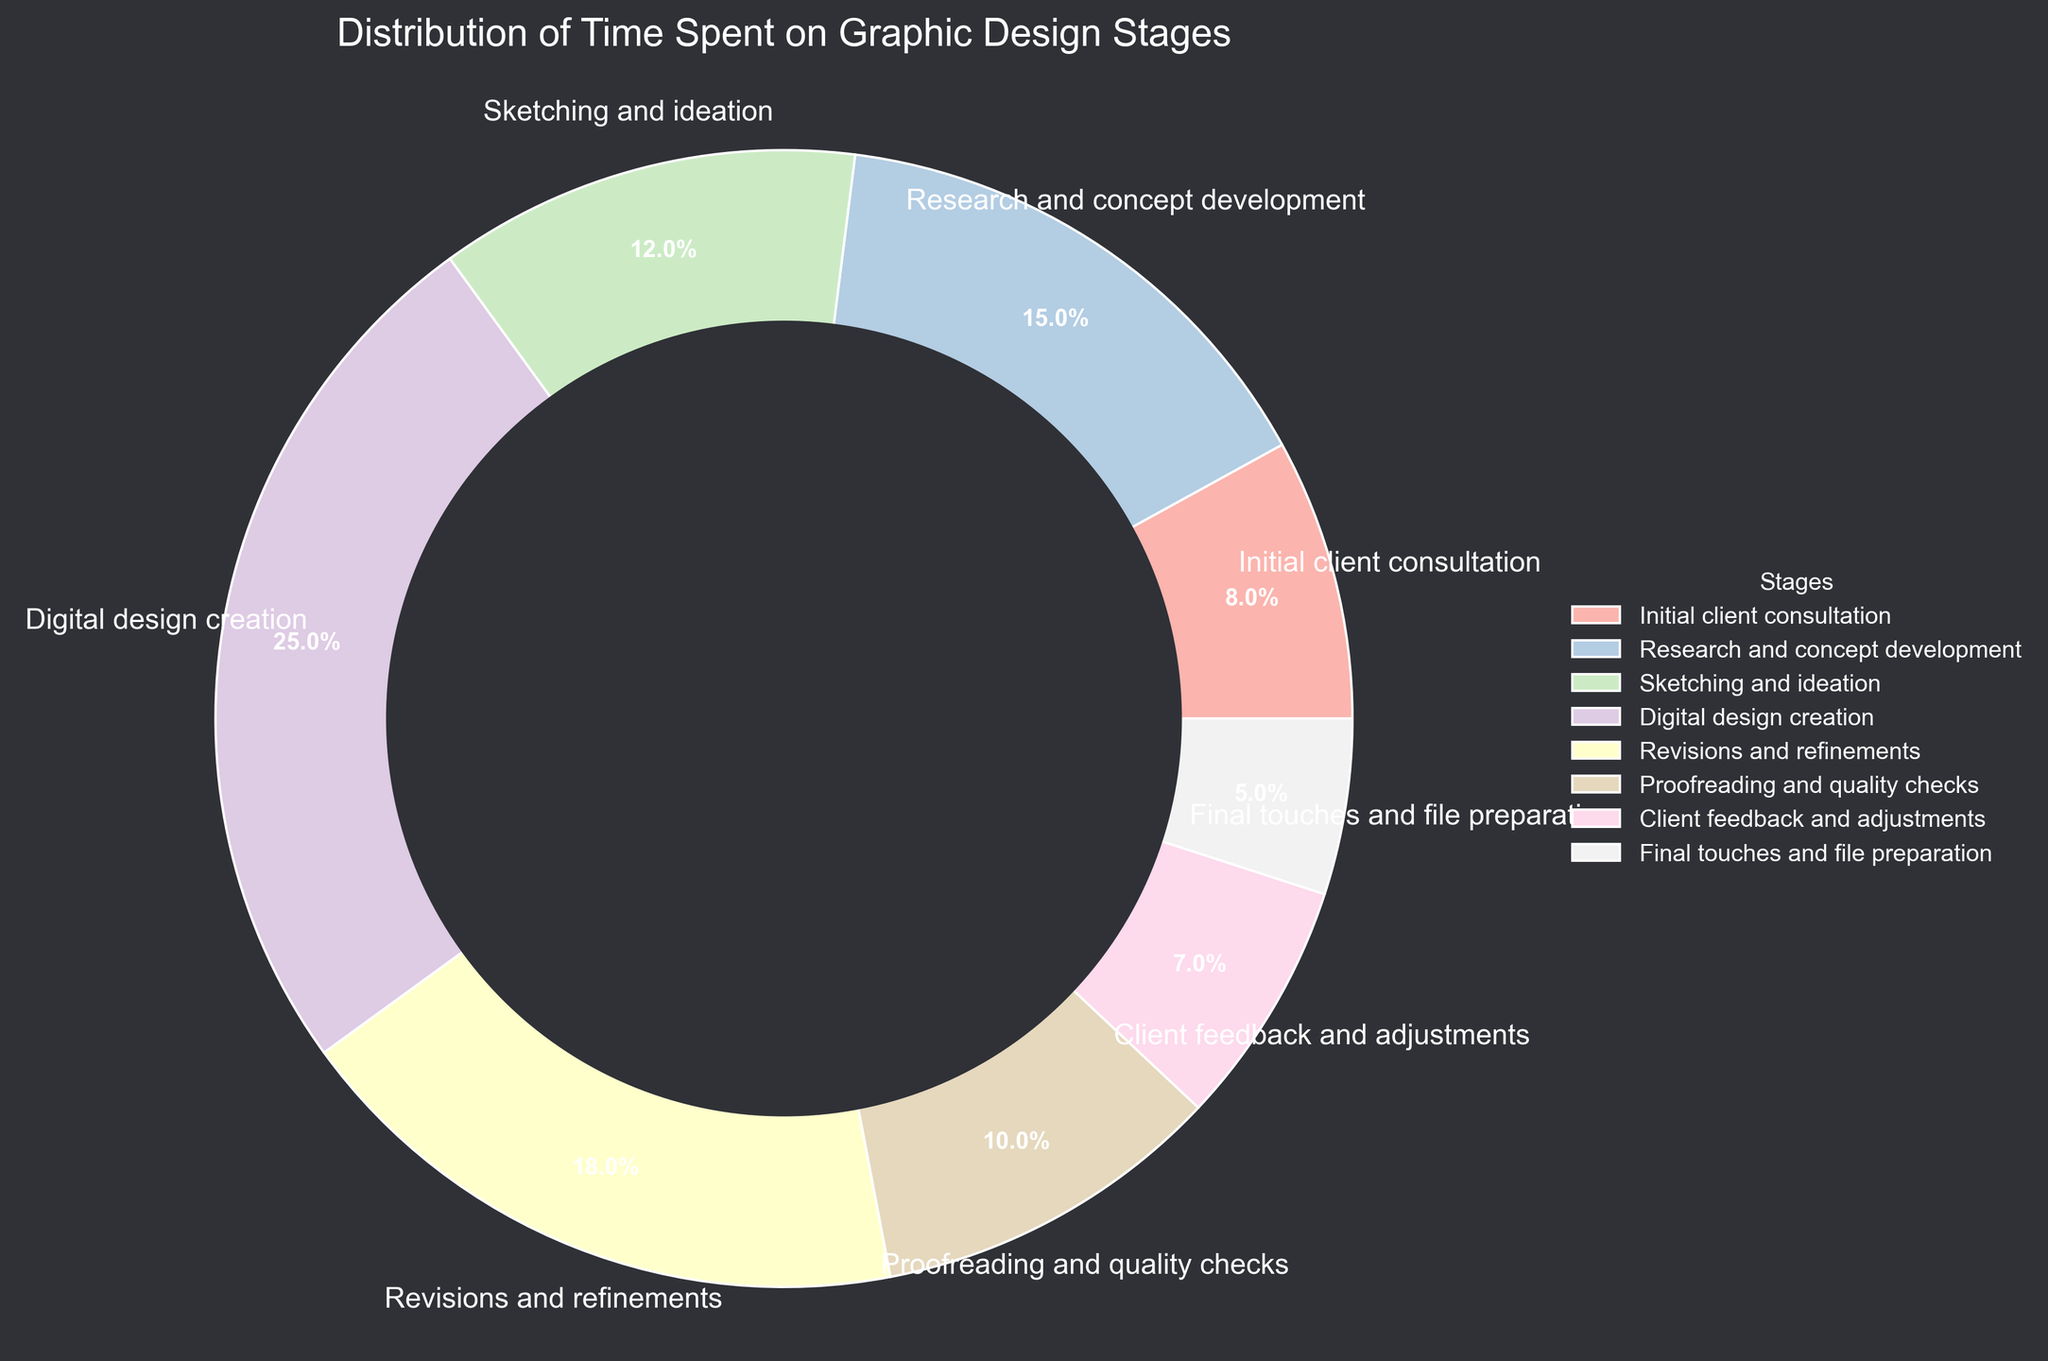What percentage of the project time is spent on digital design creation? Identify the wedge labeled "Digital design creation" in the pie chart, which shows that it occupies 25% of the chart.
Answer: 25% Which stage takes more time, research and concept development or revisions and refinements? Compare the percentage values for "Research and concept development" (15%) and "Revisions and refinements" (18%). The value for "Revisions and refinements" is higher.
Answer: Revisions and refinements What is the sum of the time spent on initial client consultation and final touches and file preparation? Add the percentages for the "Initial client consultation" (8%) and "Final touches and file preparation" (5%). 8% + 5% = 13%.
Answer: 13% What is the difference in the percentage of time spent on digital design creation and proofreading and quality checks? Subtract the percentage of "Proofreading and quality checks" (10%) from "Digital design creation" (25%). 25% - 10% = 15%.
Answer: 15% Which stage takes the least amount of time? Identify the wedge with the smallest percentage value, labeled "Final touches and file preparation", which is 5%.
Answer: Final touches and file preparation What is the combined percentage of time spent on sketching and ideation and client feedback and adjustments? Add the percentages for "Sketching and ideation" (12%) and "Client feedback and adjustments" (7%). 12% + 7% = 19%.
Answer: 19% How does the time spent on revisions and refinements compare to that on proofreading and quality checks? Compare the percentage values for "Revisions and refinements" (18%) and "Proofreading and quality checks" (10%). The value for "Revisions and refinements" is higher.
Answer: Revisions and refinements is higher What visual feature helps distinguish the wedges in the pie chart? Observe the colors and labels for each wedge, and the distinct banded separation to denote different percentages within the pie chart.
Answer: Colors and labels Which two stages together constitute 23% of the project's time? Find two stages whose percentage values add up to 23%. "Initial client consultation" (8%) and "Client feedback and adjustments" (7%) together are 15%. "Research and concept development" (15%) and "Final touches and file preparation" (5%) together are 20%. The stages "Sketching and ideation" (12%) and "Client feedback and adjustments" (7%) together add up to 23%.
Answer: Sketching and ideation and Client feedback and adjustments 